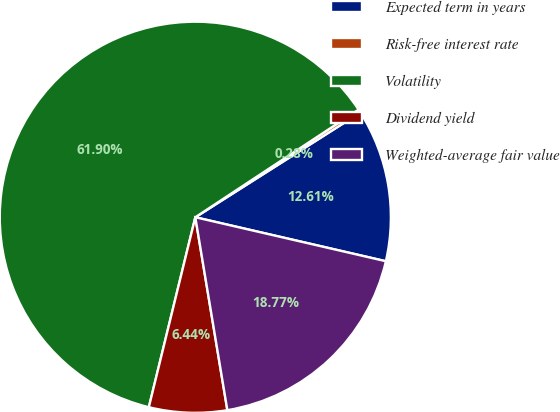Convert chart. <chart><loc_0><loc_0><loc_500><loc_500><pie_chart><fcel>Expected term in years<fcel>Risk-free interest rate<fcel>Volatility<fcel>Dividend yield<fcel>Weighted-average fair value<nl><fcel>12.61%<fcel>0.28%<fcel>61.9%<fcel>6.44%<fcel>18.77%<nl></chart> 